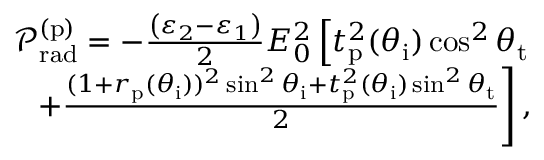Convert formula to latex. <formula><loc_0><loc_0><loc_500><loc_500>\begin{array} { r } { \mathcal { P } _ { r a d } ^ { ( p ) } = - \frac { \left ( \varepsilon _ { 2 } - \varepsilon _ { 1 } \right ) } { 2 } E _ { 0 } ^ { 2 } \left [ t _ { p } ^ { 2 } ( \theta _ { i } ) \cos ^ { 2 } \theta _ { t } } \\ { + \frac { ( 1 + r _ { p } ( \theta _ { i } ) ) ^ { 2 } \sin ^ { 2 } \theta _ { i } + t _ { p } ^ { 2 } ( \theta _ { i } ) \sin ^ { 2 } \theta _ { t } } { 2 } \right ] , } \end{array}</formula> 